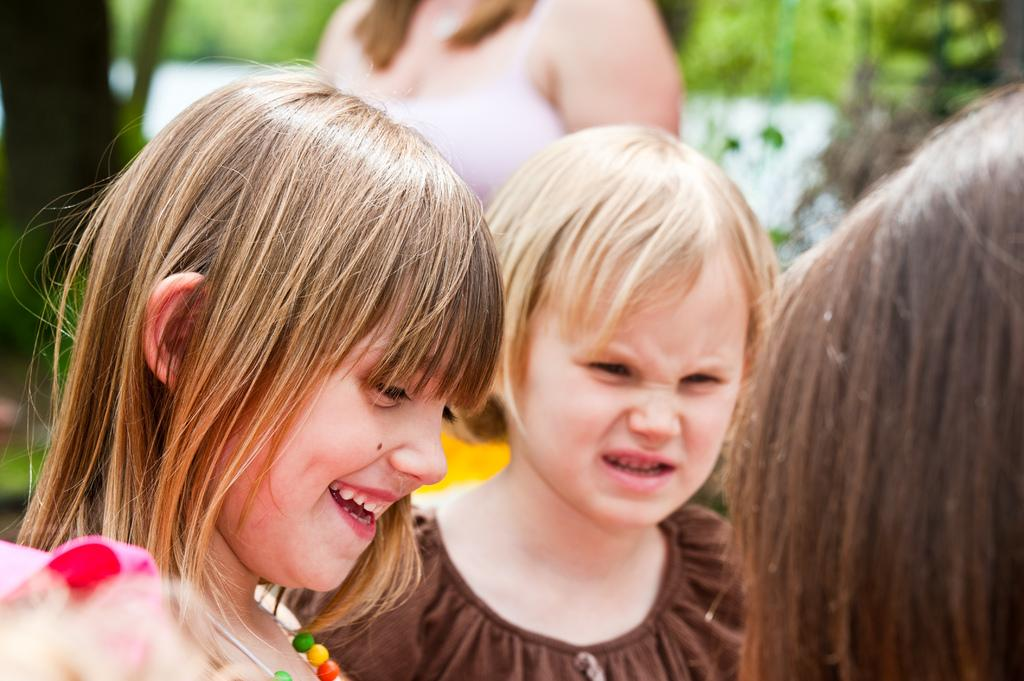What can be seen in the image? There are children in the image. What are the children wearing? The children are wearing clothes. Can you describe the girl on the left side of the image? The girl on the left side is wearing a neck chain and is smiling. How would you describe the background of the image? The background of the image is blurred. What is the price of the sun in the image? There is no sun present in the image, and therefore no price can be determined. 